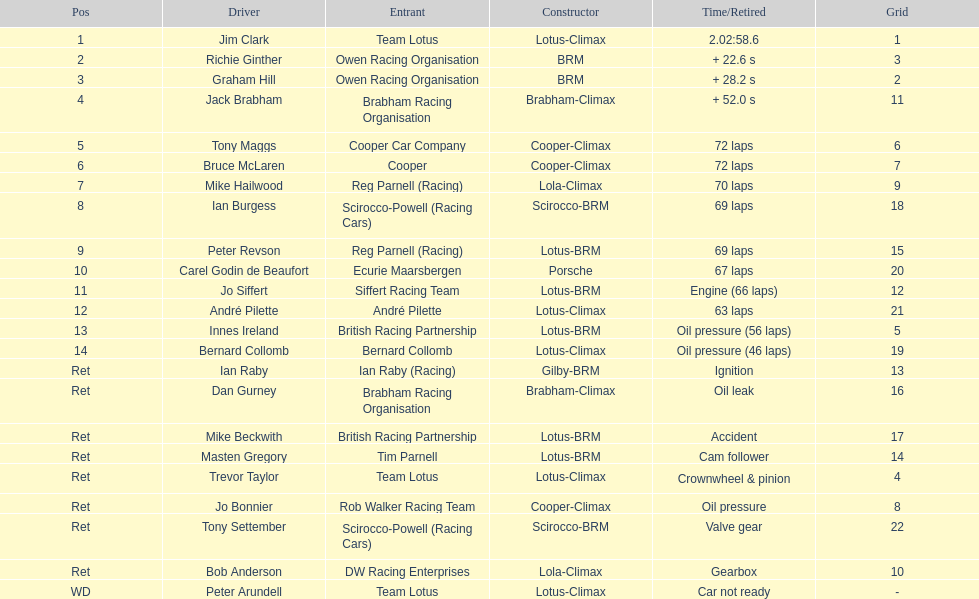Who were the two that that a similar problem? Innes Ireland. What was their common problem? Oil pressure. 